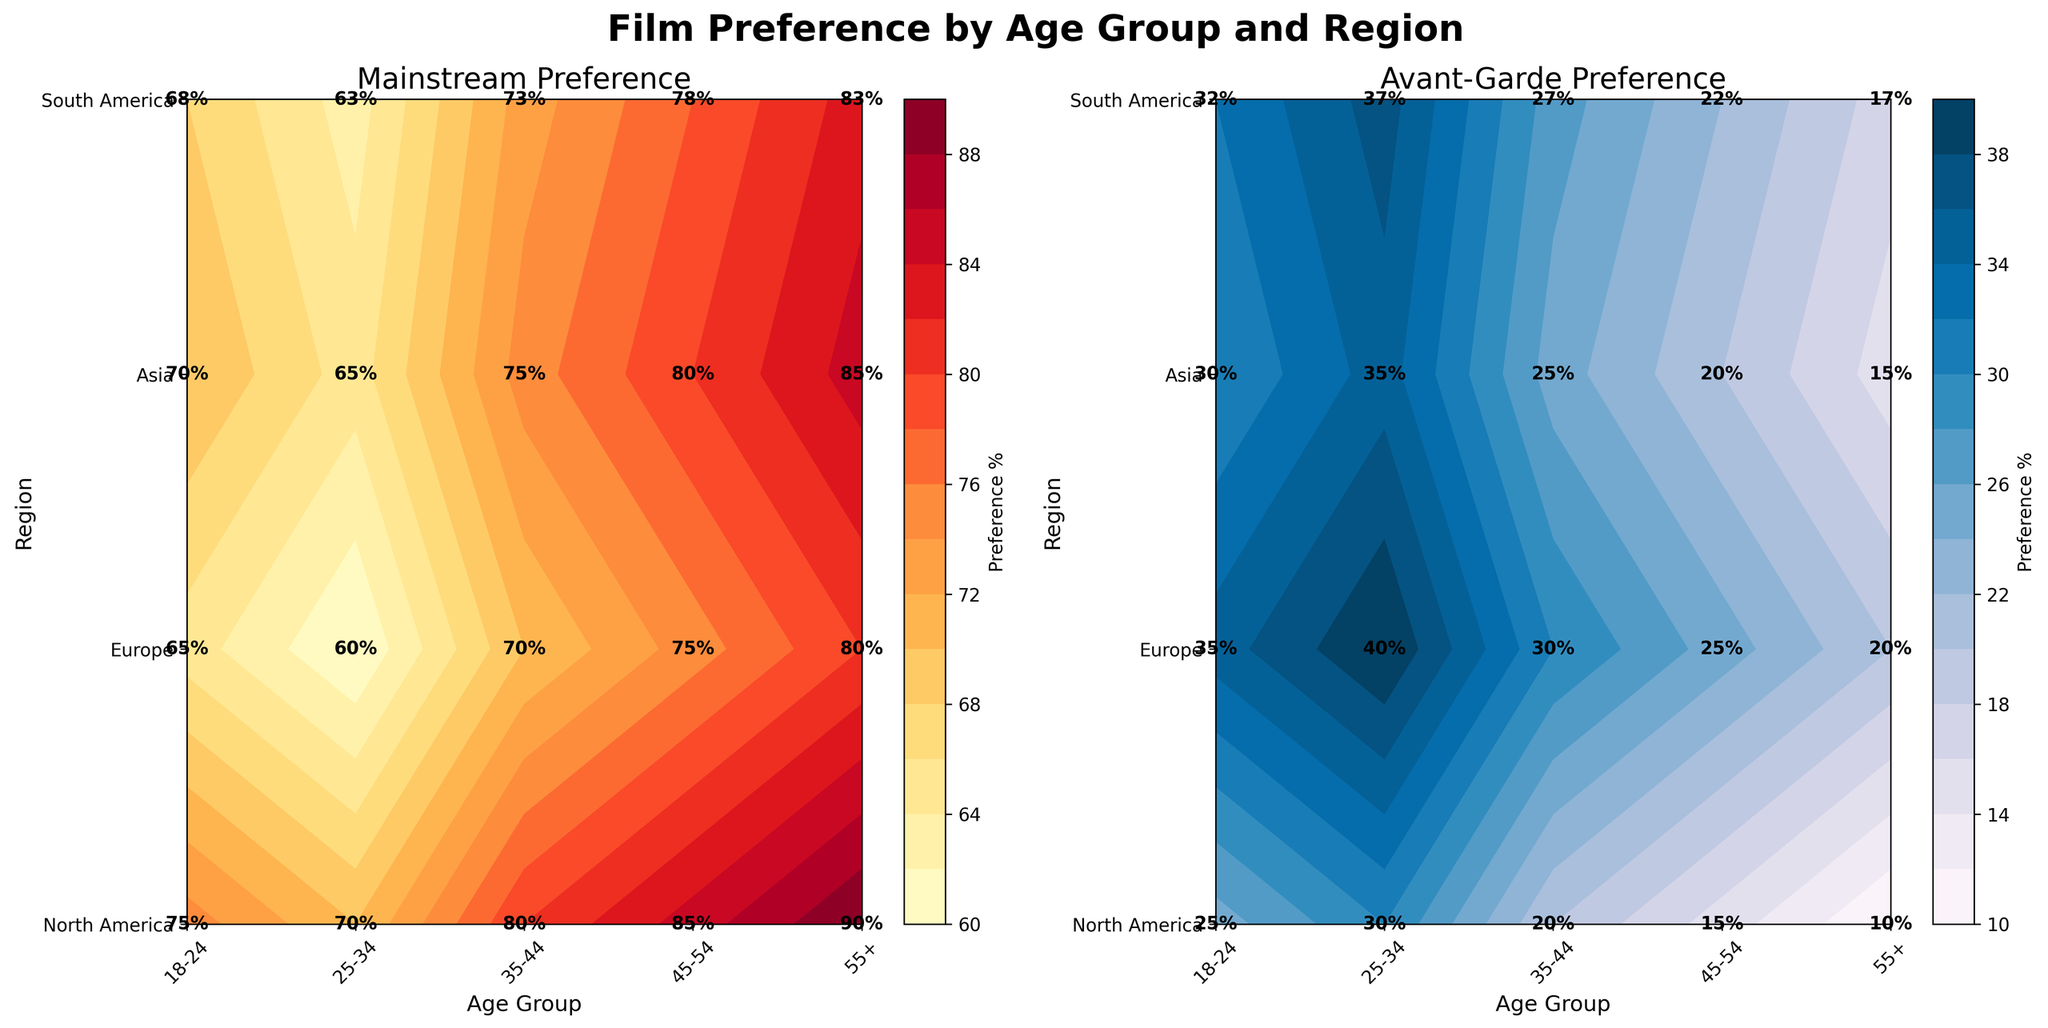What's the main title of the figure? The main title is located at the top center of the figure in bold text. Read it directly from the figure.
Answer: "Film Preference by Age Group and Region" Which age group in North America has the highest preference for mainstream films? First, focus on the 'Mainstream Preference' contour plot for North America. Then, identify the age group with the highest percentage value in the North America row. Look at the text annotations for quick identification.
Answer: 55+ How does the preference for avant-garde films change with age in Asia? Look at the 'Avant-Garde Preference' contour plot for the Asian region. Move from the youngest age group (18-24) to the oldest (55+). Notice the numbers decrease.
Answer: It decreases In which region do older age groups (55+) show the least preference for avant-garde films? Compare the 'Avant-Garde Preference' percentages for the 55+ age group across all regions. Locate the lowest percentage.
Answer: Asia What's the difference in mainstream preference between the 25-34 and 45-54 age groups in Europe? Check the 'Mainstream Preference' for the age groups 25-34 and 45-54 in Europe. Subtract the percentage for 25-34 from the percentage for 45-54.
Answer: 15% Which age group shows the most equal preference for mainstream and avant-garde films in South America? Both plots show their respective preferences. Identify the age group in South America where the percentages are closest to each other.
Answer: 25-34 What is the sum of mainstream preferences for the age group 35-44 across all regions? Sum the percentages of mainstream preference for 35-44 age group in North America, Europe, Asia, and South America.
Answer: 298% Which region has the most distinct difference between mainstream and avant-garde preferences across all age groups? Examine both the 'Mainstream Preference' and 'Avant-Garde Preference' contour plots across all regions. Identify the region with the largest differences in preference values.
Answer: Asia How does the preference for mainstream films change with age in Europe? Observe the 'Mainstream Preference' plot for European regions, moving from the youngest (18-24) to the oldest (55+). Notice if the values increase or decrease.
Answer: It increases Compare the avant-garde preferences between North America and South America for the 18-24 age group. Look at the 'Avant-Garde Preference' contour plot for the 18-24 age group in both North America and South America. Determine which has a higher percentage.
Answer: South America 